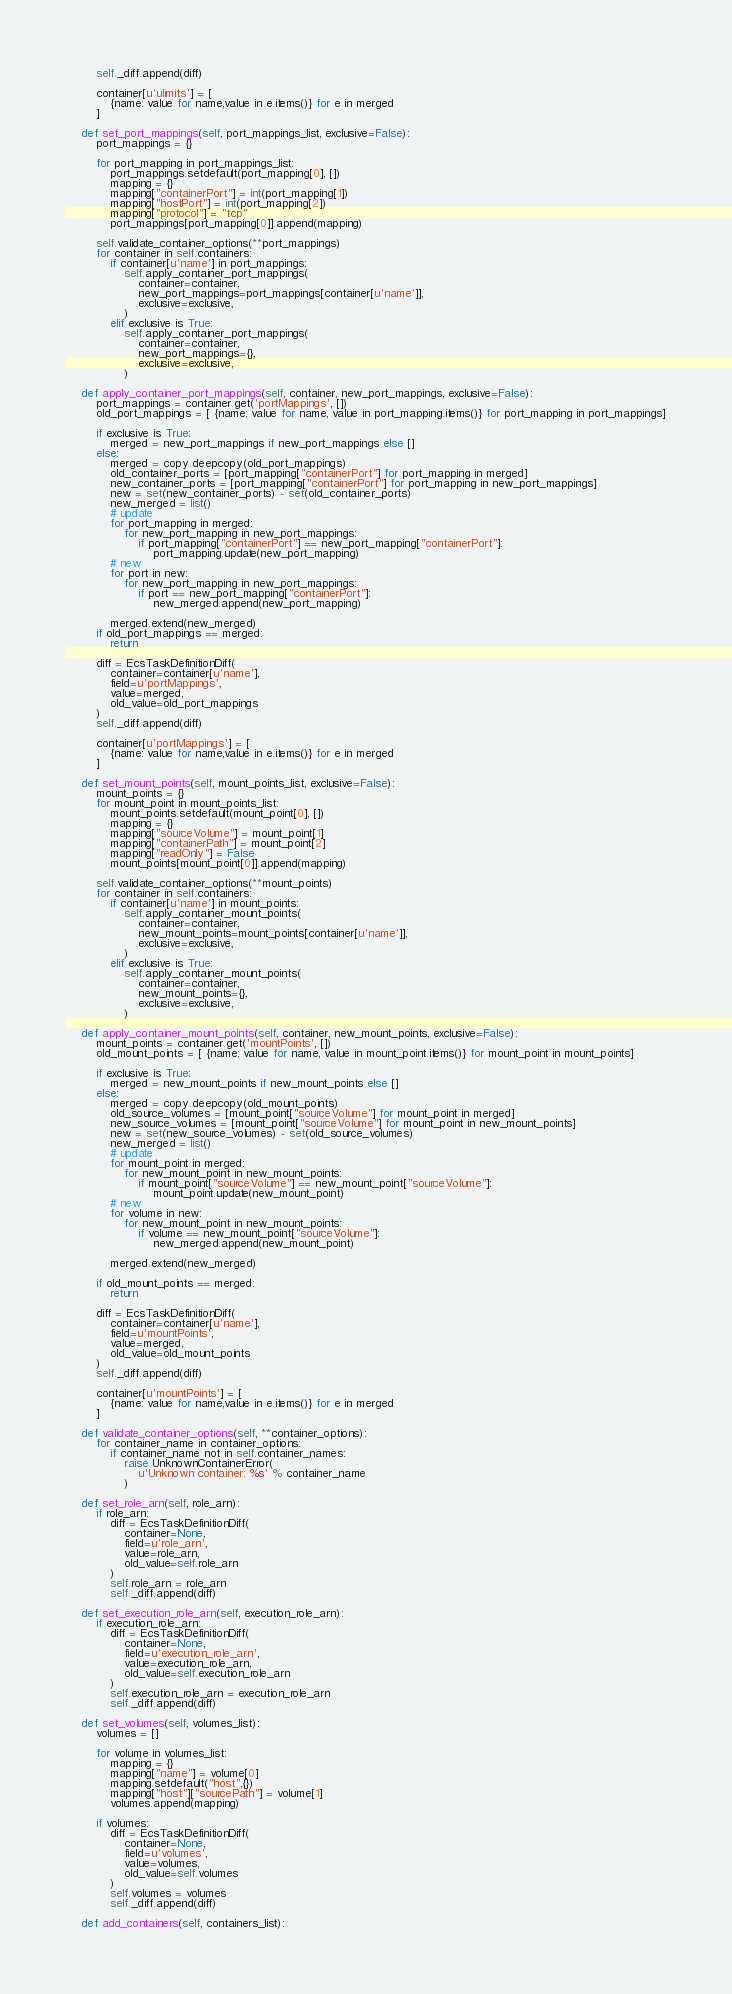<code> <loc_0><loc_0><loc_500><loc_500><_Python_>        self._diff.append(diff)

        container[u'ulimits'] = [
            {name: value for name,value in e.items()} for e in merged
        ]

    def set_port_mappings(self, port_mappings_list, exclusive=False):
        port_mappings = {}

        for port_mapping in port_mappings_list:
            port_mappings.setdefault(port_mapping[0], [])
            mapping = {}
            mapping["containerPort"] = int(port_mapping[1])
            mapping["hostPort"] = int(port_mapping[2])
            mapping["protocol"] = "tcp"
            port_mappings[port_mapping[0]].append(mapping)

        self.validate_container_options(**port_mappings)
        for container in self.containers:
            if container[u'name'] in port_mappings:
                self.apply_container_port_mappings(
                    container=container,
                    new_port_mappings=port_mappings[container[u'name']],
                    exclusive=exclusive,
                )
            elif exclusive is True:
                self.apply_container_port_mappings(
                    container=container,
                    new_port_mappings={},
                    exclusive=exclusive,
                )

    def apply_container_port_mappings(self, container, new_port_mappings, exclusive=False):
        port_mappings = container.get('portMappings', [])
        old_port_mappings = [ {name: value for name, value in port_mapping.items()} for port_mapping in port_mappings]

        if exclusive is True:
            merged = new_port_mappings if new_port_mappings else []
        else:
            merged = copy.deepcopy(old_port_mappings)
            old_container_ports = [port_mapping["containerPort"] for port_mapping in merged]
            new_container_ports = [port_mapping["containerPort"] for port_mapping in new_port_mappings]
            new = set(new_container_ports) - set(old_container_ports)
            new_merged = list()
            # update
            for port_mapping in merged:
                for new_port_mapping in new_port_mappings:
                    if port_mapping["containerPort"] == new_port_mapping["containerPort"]:
                        port_mapping.update(new_port_mapping)
            # new
            for port in new:
                for new_port_mapping in new_port_mappings:
                    if port == new_port_mapping["containerPort"]:
                        new_merged.append(new_port_mapping)

            merged.extend(new_merged)
        if old_port_mappings == merged:
            return

        diff = EcsTaskDefinitionDiff(
            container=container[u'name'],
            field=u'portMappings',
            value=merged,
            old_value=old_port_mappings
        )
        self._diff.append(diff)

        container[u'portMappings'] = [
            {name: value for name,value in e.items()} for e in merged
        ]

    def set_mount_points(self, mount_points_list, exclusive=False):
        mount_points = {}
        for mount_point in mount_points_list:
            mount_points.setdefault(mount_point[0], [])
            mapping = {}
            mapping["sourceVolume"] = mount_point[1]
            mapping["containerPath"] = mount_point[2]
            mapping["readOnly"] = False
            mount_points[mount_point[0]].append(mapping)

        self.validate_container_options(**mount_points)
        for container in self.containers:
            if container[u'name'] in mount_points:
                self.apply_container_mount_points(
                    container=container,
                    new_mount_points=mount_points[container[u'name']],
                    exclusive=exclusive,
                )
            elif exclusive is True:
                self.apply_container_mount_points(
                    container=container,
                    new_mount_points={},
                    exclusive=exclusive,
                )

    def apply_container_mount_points(self, container, new_mount_points, exclusive=False):
        mount_points = container.get('mountPoints', [])
        old_mount_points = [ {name: value for name, value in mount_point.items()} for mount_point in mount_points]

        if exclusive is True:
            merged = new_mount_points if new_mount_points else []
        else:
            merged = copy.deepcopy(old_mount_points)
            old_source_volumes = [mount_point["sourceVolume"] for mount_point in merged]
            new_source_volumes = [mount_point["sourceVolume"] for mount_point in new_mount_points]
            new = set(new_source_volumes) - set(old_source_volumes)
            new_merged = list()
            # update
            for mount_point in merged:
                for new_mount_point in new_mount_points:
                    if mount_point["sourceVolume"] == new_mount_point["sourceVolume"]:
                        mount_point.update(new_mount_point)
            # new
            for volume in new:
                for new_mount_point in new_mount_points:
                    if volume == new_mount_point["sourceVolume"]:
                        new_merged.append(new_mount_point)

            merged.extend(new_merged)

        if old_mount_points == merged:
            return

        diff = EcsTaskDefinitionDiff(
            container=container[u'name'],
            field=u'mountPoints',
            value=merged,
            old_value=old_mount_points
        )
        self._diff.append(diff)

        container[u'mountPoints'] = [
            {name: value for name,value in e.items()} for e in merged
        ]

    def validate_container_options(self, **container_options):
        for container_name in container_options:
            if container_name not in self.container_names:
                raise UnknownContainerError(
                    u'Unknown container: %s' % container_name
                )

    def set_role_arn(self, role_arn):
        if role_arn:
            diff = EcsTaskDefinitionDiff(
                container=None,
                field=u'role_arn',
                value=role_arn,
                old_value=self.role_arn
            )
            self.role_arn = role_arn
            self._diff.append(diff)

    def set_execution_role_arn(self, execution_role_arn):
        if execution_role_arn:
            diff = EcsTaskDefinitionDiff(
                container=None,
                field=u'execution_role_arn',
                value=execution_role_arn,
                old_value=self.execution_role_arn
            )
            self.execution_role_arn = execution_role_arn
            self._diff.append(diff)

    def set_volumes(self, volumes_list):
        volumes = []

        for volume in volumes_list:
            mapping = {}
            mapping["name"] = volume[0]
            mapping.setdefault("host",{})
            mapping["host"]["sourcePath"] = volume[1]
            volumes.append(mapping)

        if volumes:
            diff = EcsTaskDefinitionDiff(
                container=None,
                field=u'volumes',
                value=volumes,
                old_value=self.volumes
            )
            self.volumes = volumes
            self._diff.append(diff)

    def add_containers(self, containers_list):</code> 